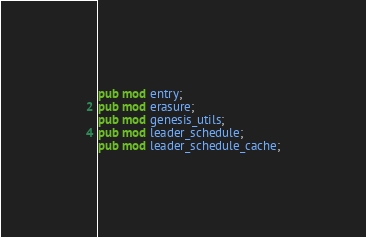Convert code to text. <code><loc_0><loc_0><loc_500><loc_500><_Rust_>pub mod entry;
pub mod erasure;
pub mod genesis_utils;
pub mod leader_schedule;
pub mod leader_schedule_cache;</code> 